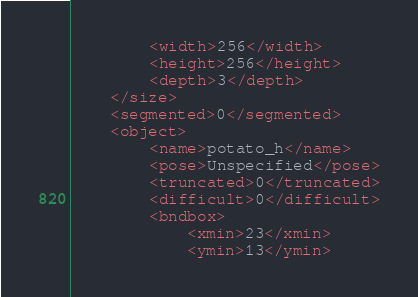<code> <loc_0><loc_0><loc_500><loc_500><_XML_>		<width>256</width>
		<height>256</height>
		<depth>3</depth>
	</size>
	<segmented>0</segmented>
	<object>
		<name>potato_h</name>
		<pose>Unspecified</pose>
		<truncated>0</truncated>
		<difficult>0</difficult>
		<bndbox>
			<xmin>23</xmin>
			<ymin>13</ymin></code> 